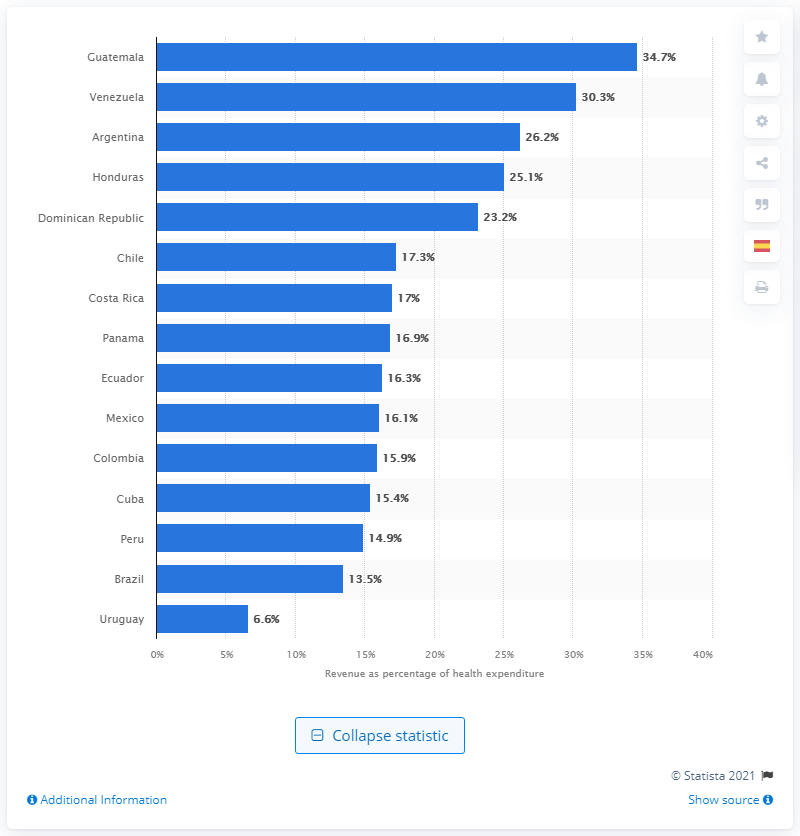Give some essential details in this illustration. According to data from 2014, the pharmaceutical industry generated 26.2% of Argentina's total health expenditures. 